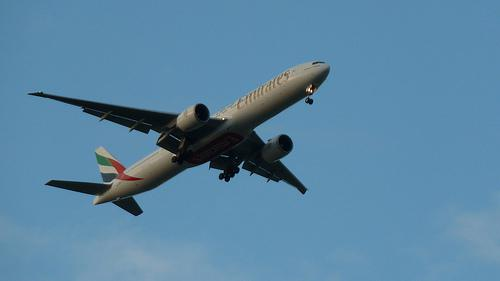Question: what name is on the plane?
Choices:
A. Emtrates.
B. United.
C. American.
D. Southwest.
Answer with the letter. Answer: A Question: what color is the plane?
Choices:
A. White.
B. Black.
C. Gray.
D. Blue.
Answer with the letter. Answer: C Question: how many wheels are on the front?
Choices:
A. 4.
B. 1.
C. 3.
D. 2.
Answer with the letter. Answer: D 